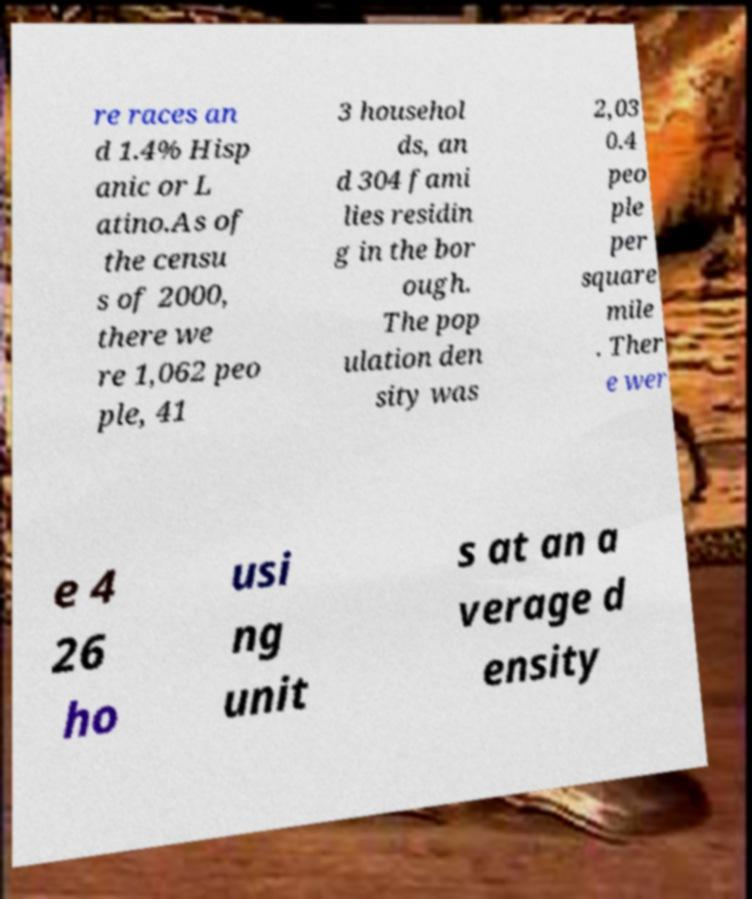Please read and relay the text visible in this image. What does it say? re races an d 1.4% Hisp anic or L atino.As of the censu s of 2000, there we re 1,062 peo ple, 41 3 househol ds, an d 304 fami lies residin g in the bor ough. The pop ulation den sity was 2,03 0.4 peo ple per square mile . Ther e wer e 4 26 ho usi ng unit s at an a verage d ensity 